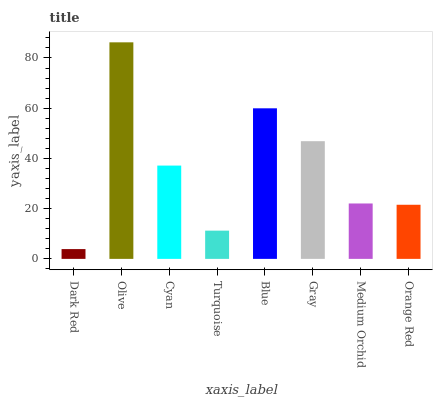Is Dark Red the minimum?
Answer yes or no. Yes. Is Olive the maximum?
Answer yes or no. Yes. Is Cyan the minimum?
Answer yes or no. No. Is Cyan the maximum?
Answer yes or no. No. Is Olive greater than Cyan?
Answer yes or no. Yes. Is Cyan less than Olive?
Answer yes or no. Yes. Is Cyan greater than Olive?
Answer yes or no. No. Is Olive less than Cyan?
Answer yes or no. No. Is Cyan the high median?
Answer yes or no. Yes. Is Medium Orchid the low median?
Answer yes or no. Yes. Is Medium Orchid the high median?
Answer yes or no. No. Is Dark Red the low median?
Answer yes or no. No. 